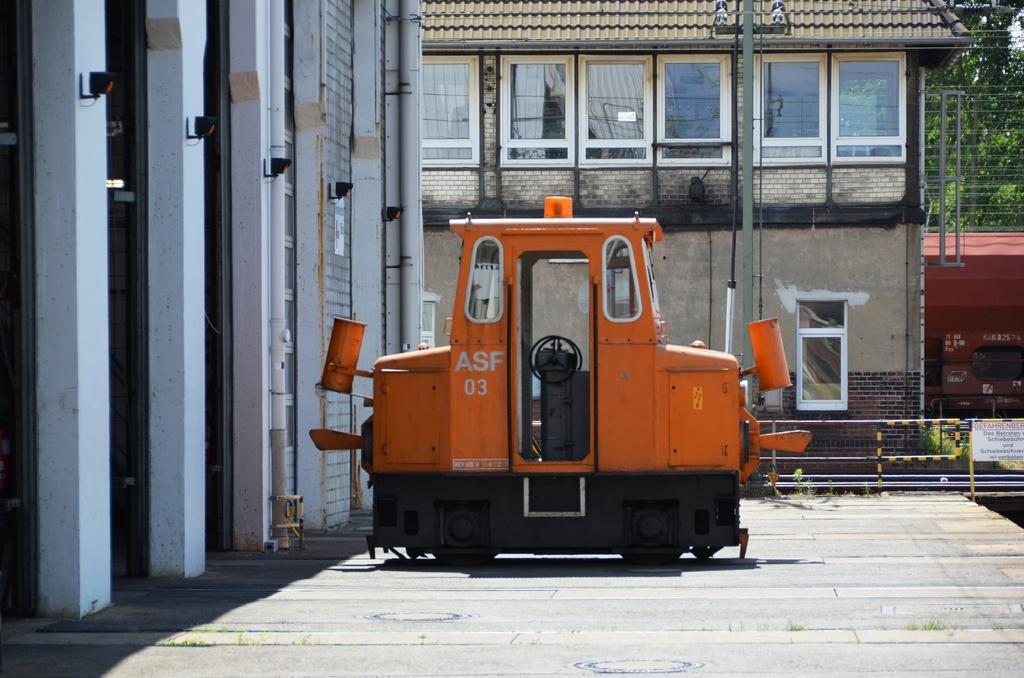Describe this image in one or two sentences. In this image we can see a motor vehicle on the road, buildings, windows, curtains, pipelines, electric lights, trees and sky. 